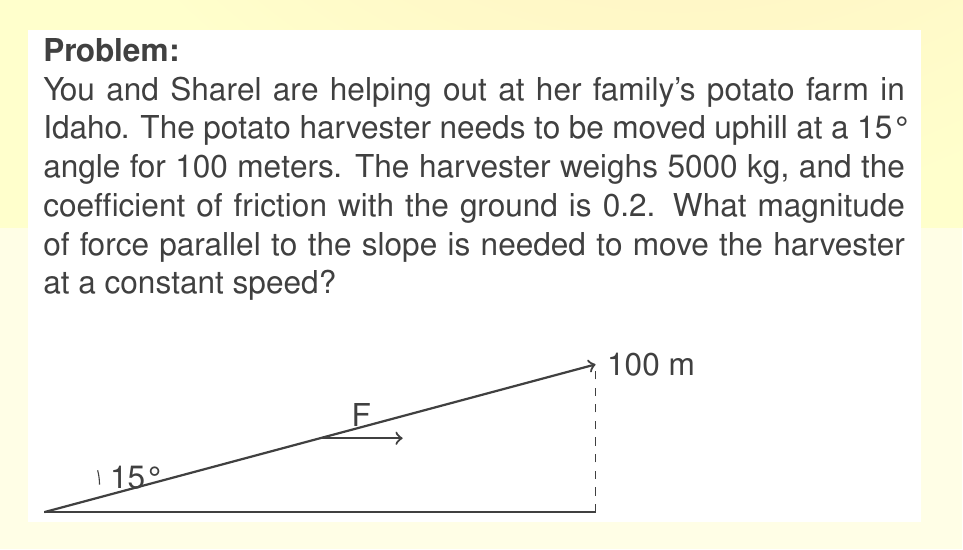What is the answer to this math problem? Let's approach this step-by-step:

1) First, we need to consider the forces acting on the harvester:
   - Weight (W): $W = mg = 5000 \cdot 9.8 = 49000$ N (downward)
   - Normal force (N): perpendicular to the slope
   - Friction force (f): parallel to the slope, opposing motion
   - Applied force (F): parallel to the slope, in the direction of motion

2) We need to find the component of weight parallel to the slope:
   $W_\parallel = W \sin(15°) = 49000 \cdot 0.2588 = 12681.2$ N

3) The normal force is the component of weight perpendicular to the slope:
   $N = W \cos(15°) = 49000 \cdot 0.9659 = 47329.1$ N

4) The friction force is given by:
   $f = \mu N = 0.2 \cdot 47329.1 = 9465.82$ N

5) For constant speed, the net force should be zero. So:
   $F - f - W_\parallel = 0$

6) Solving for F:
   $F = f + W_\parallel = 9465.82 + 12681.2 = 22147.02$ N

Therefore, a force of approximately 22147 N parallel to the slope is needed to move the harvester at a constant speed.
Answer: $22147$ N 